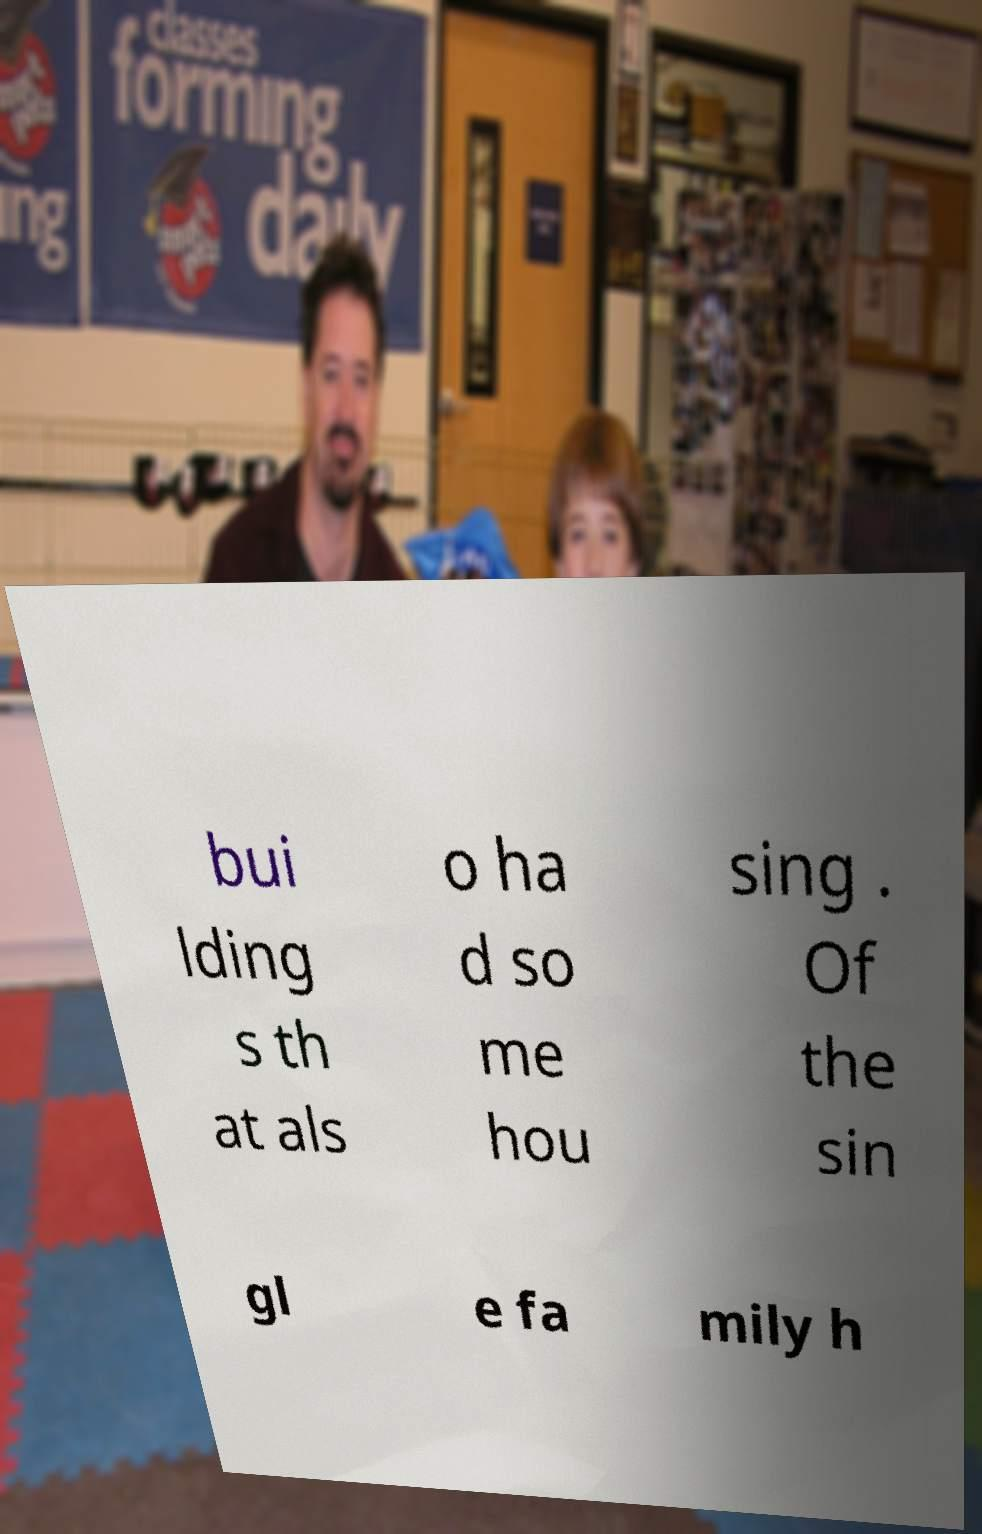For documentation purposes, I need the text within this image transcribed. Could you provide that? bui lding s th at als o ha d so me hou sing . Of the sin gl e fa mily h 